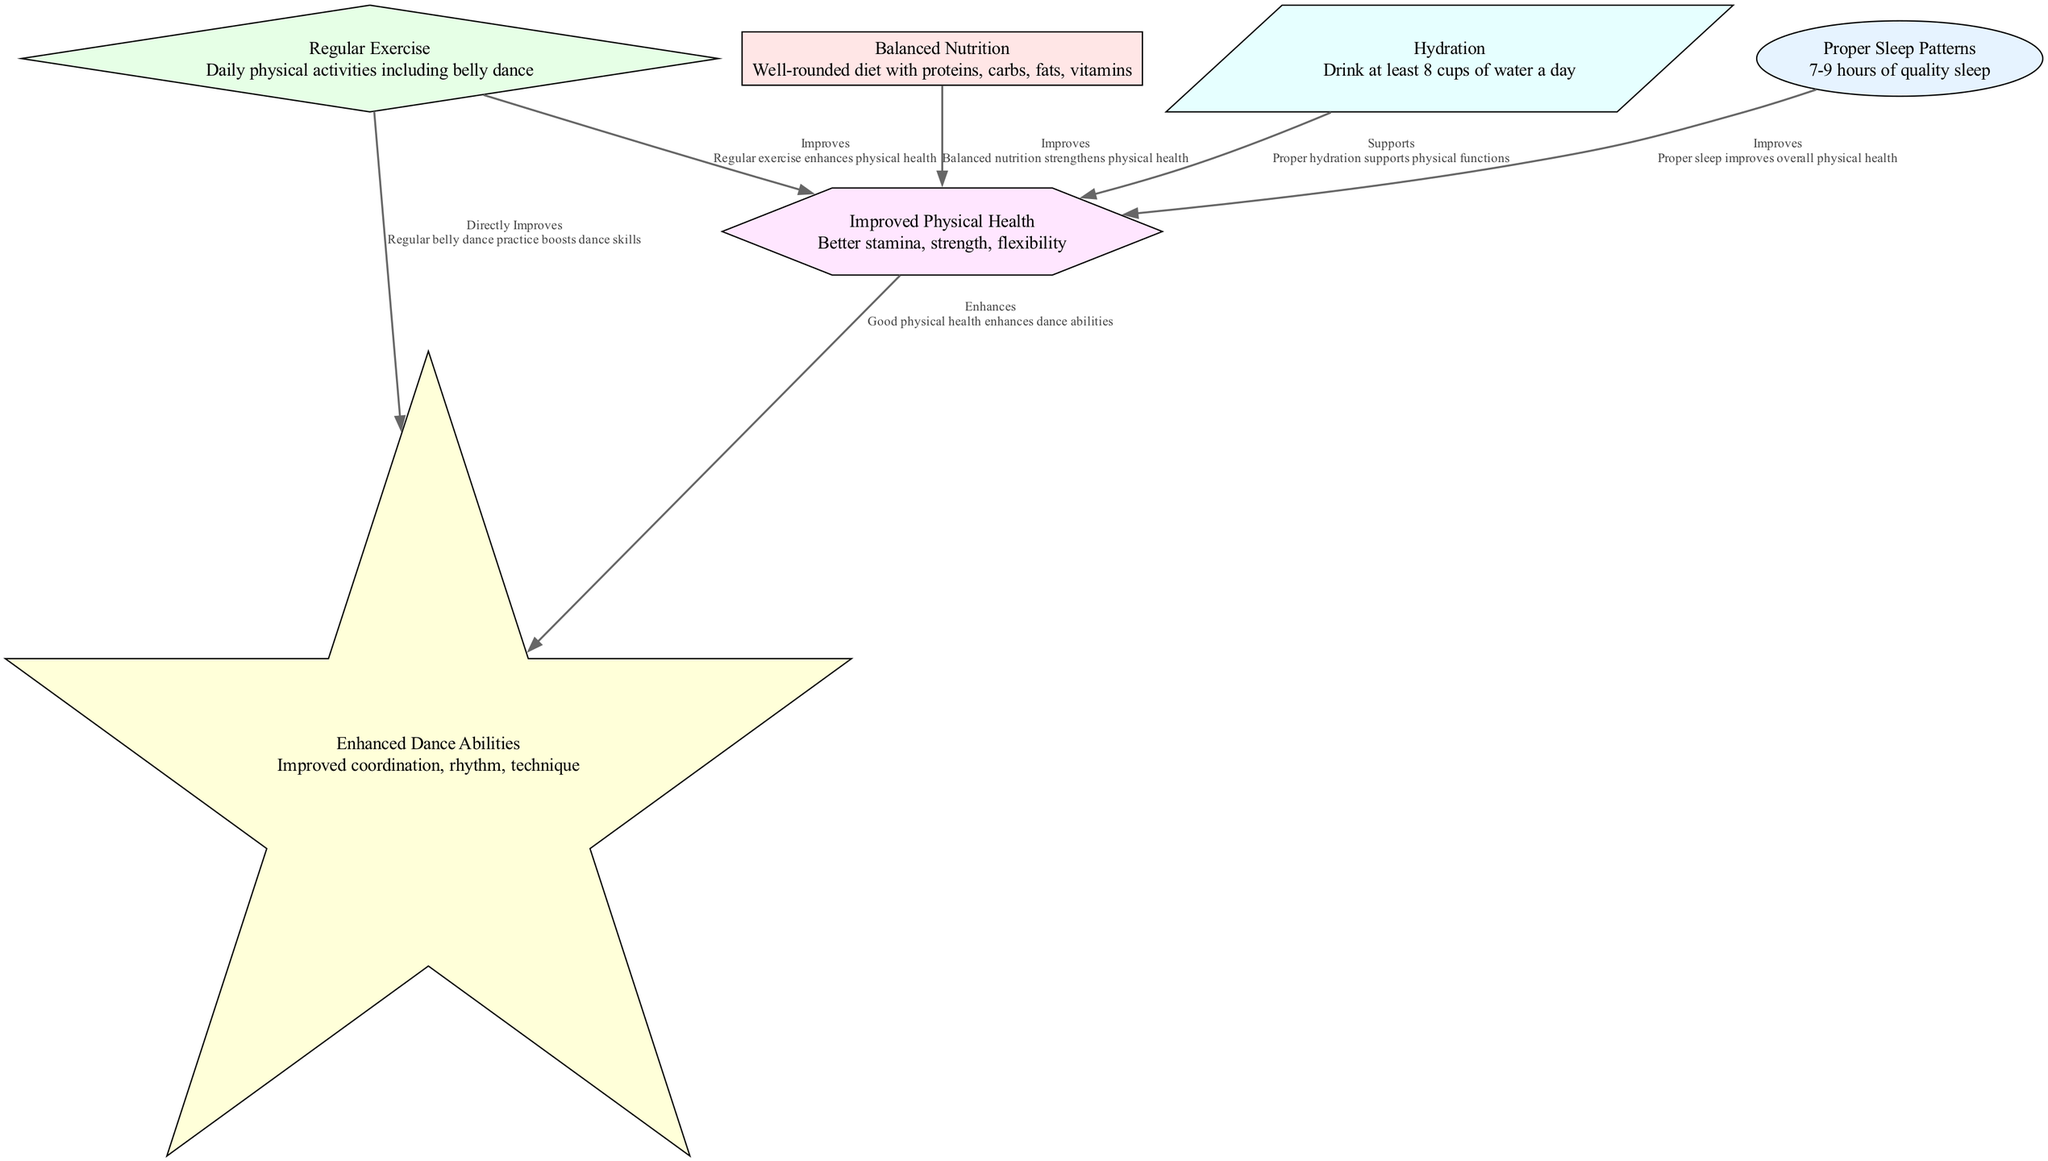What are the three main nodes associated with physical health? The diagram shows three main nodes that contribute to improved physical health: Proper Sleep Patterns, Balanced Nutrition, and Regular Exercise. Each of these nodes has a direct relationship with Improved Physical Health.
Answer: Proper Sleep Patterns, Balanced Nutrition, Regular Exercise How many edges connect the "Regular Exercise" node to other nodes? In the diagram, the "Regular Exercise" node connects to two other nodes: it improves physical health and directly improves dance abilities. Therefore, there are two edges connecting this node.
Answer: 2 What does "Hydration" support according to the diagram? According to the diagram, the "Hydration" node supports the "Improved Physical Health" node. This means that proper hydration is crucial for maintaining physical health.
Answer: Improved Physical Health Which node directly improves dance abilities? The node labeled "Regular Exercise" has a direct edge that states it directly improves dance abilities. This signifies that engaging in physical exercise, particularly belly dance, enhances dancing skills.
Answer: Regular Exercise How many total nodes are present in the diagram? The diagram contains six nodes in total, each representing a different aspect of a healthy lifestyle or its outcomes.
Answer: 6 What relationship exists between "Improved Physical Health" and "Enhanced Dance Abilities"? The relationship between "Improved Physical Health" and "Enhanced Dance Abilities" is expressed as "Enhances," indicating that better physical health contributes positively to dance skills.
Answer: Enhances What daily physical activity is explicitly mentioned in the diagram? The diagram explicitly mentions "belly dance" as a form of daily physical activity included in the "Regular Exercise" node. This highlights its importance in maintaining a healthy lifestyle and improving dance skills.
Answer: belly dance Which lifestyle factor is related to receiving quality rest overnight? The factor related to receiving quality rest overnight is "Proper Sleep Patterns." This node emphasizes the importance of quality sleep for general health and well-being.
Answer: Proper Sleep Patterns 